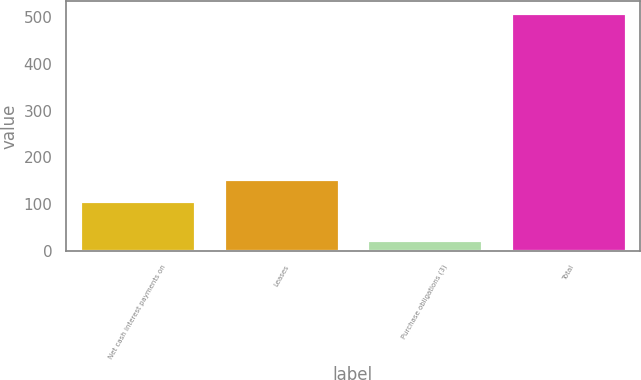<chart> <loc_0><loc_0><loc_500><loc_500><bar_chart><fcel>Net cash interest payments on<fcel>Leases<fcel>Purchase obligations (3)<fcel>Total<nl><fcel>106<fcel>154.4<fcel>24<fcel>508<nl></chart> 